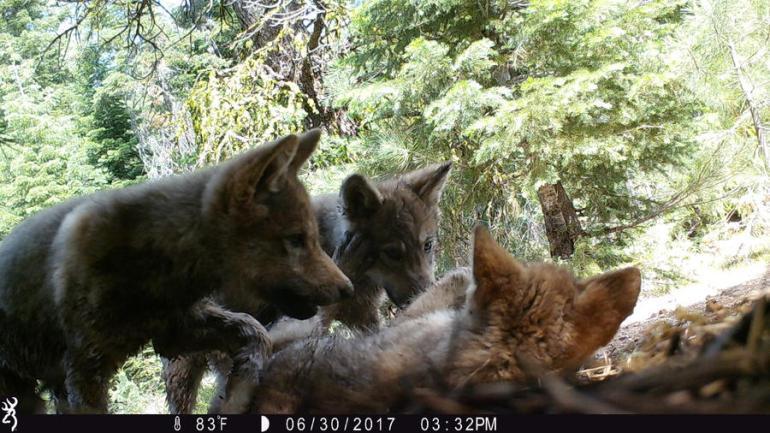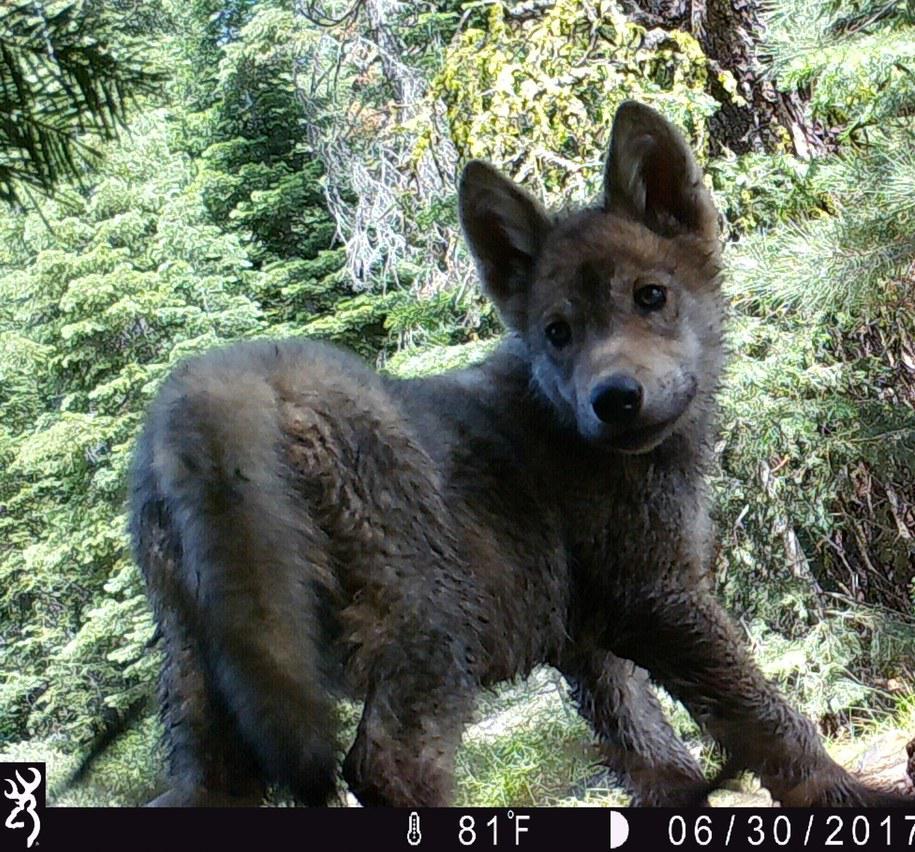The first image is the image on the left, the second image is the image on the right. Evaluate the accuracy of this statement regarding the images: "There is one dog outside in the image on the right.". Is it true? Answer yes or no. Yes. 